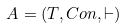<formula> <loc_0><loc_0><loc_500><loc_500>A = ( T , C o n , \vdash )</formula> 